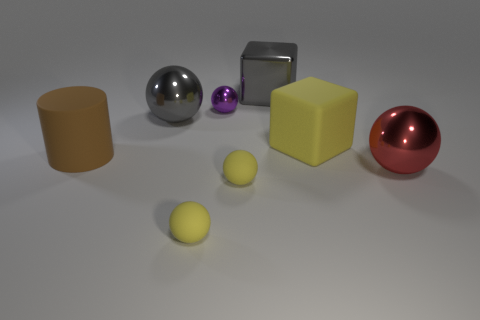There is a large metal sphere behind the shiny sphere that is right of the gray block; how many metal objects are on the right side of it?
Offer a terse response. 3. Are there more big brown metal cylinders than brown cylinders?
Your answer should be very brief. No. How many metal objects are there?
Make the answer very short. 4. There is a yellow matte object right of the big gray shiny thing on the right side of the big metallic ball that is left of the big red ball; what is its shape?
Provide a succinct answer. Cube. Is the number of big things in front of the purple ball less than the number of purple spheres that are on the right side of the large gray cube?
Your answer should be compact. No. There is a metallic object that is in front of the large yellow thing; is it the same shape as the big thing that is behind the gray shiny sphere?
Give a very brief answer. No. The shiny thing in front of the large ball behind the big red sphere is what shape?
Provide a short and direct response. Sphere. What size is the metallic thing that is the same color as the big metallic cube?
Keep it short and to the point. Large. Are there any cyan balls that have the same material as the cylinder?
Make the answer very short. No. What is the material of the large sphere that is in front of the large brown cylinder?
Your answer should be compact. Metal. 